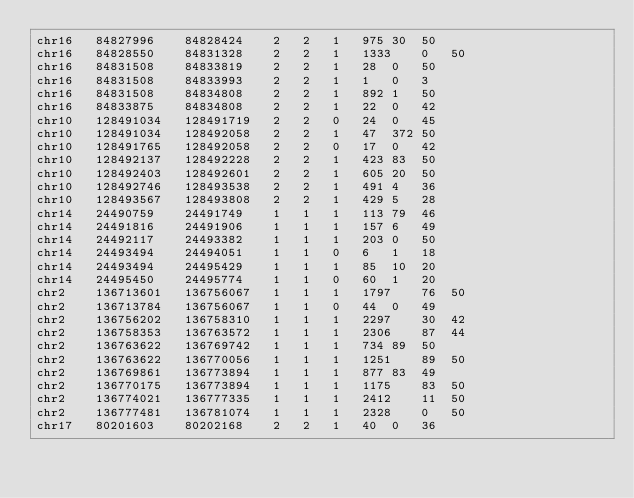<code> <loc_0><loc_0><loc_500><loc_500><_SQL_>chr16	84827996	84828424	2	2	1	975	30	50
chr16	84828550	84831328	2	2	1	1333	0	50
chr16	84831508	84833819	2	2	1	28	0	50
chr16	84831508	84833993	2	2	1	1	0	3
chr16	84831508	84834808	2	2	1	892	1	50
chr16	84833875	84834808	2	2	1	22	0	42
chr10	128491034	128491719	2	2	0	24	0	45
chr10	128491034	128492058	2	2	1	47	372	50
chr10	128491765	128492058	2	2	0	17	0	42
chr10	128492137	128492228	2	2	1	423	83	50
chr10	128492403	128492601	2	2	1	605	20	50
chr10	128492746	128493538	2	2	1	491	4	36
chr10	128493567	128493808	2	2	1	429	5	28
chr14	24490759	24491749	1	1	1	113	79	46
chr14	24491816	24491906	1	1	1	157	6	49
chr14	24492117	24493382	1	1	1	203	0	50
chr14	24493494	24494051	1	1	0	6	1	18
chr14	24493494	24495429	1	1	1	85	10	20
chr14	24495450	24495774	1	1	0	60	1	20
chr2	136713601	136756067	1	1	1	1797	76	50
chr2	136713784	136756067	1	1	0	44	0	49
chr2	136756202	136758310	1	1	1	2297	30	42
chr2	136758353	136763572	1	1	1	2306	87	44
chr2	136763622	136769742	1	1	1	734	89	50
chr2	136763622	136770056	1	1	1	1251	89	50
chr2	136769861	136773894	1	1	1	877	83	49
chr2	136770175	136773894	1	1	1	1175	83	50
chr2	136774021	136777335	1	1	1	2412	11	50
chr2	136777481	136781074	1	1	1	2328	0	50
chr17	80201603	80202168	2	2	1	40	0	36</code> 